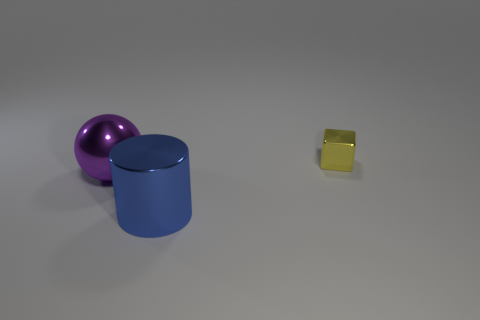Add 1 cylinders. How many objects exist? 4 Subtract all spheres. How many objects are left? 2 Subtract all large metal spheres. Subtract all cylinders. How many objects are left? 1 Add 3 small metal blocks. How many small metal blocks are left? 4 Add 3 purple balls. How many purple balls exist? 4 Subtract 1 yellow cubes. How many objects are left? 2 